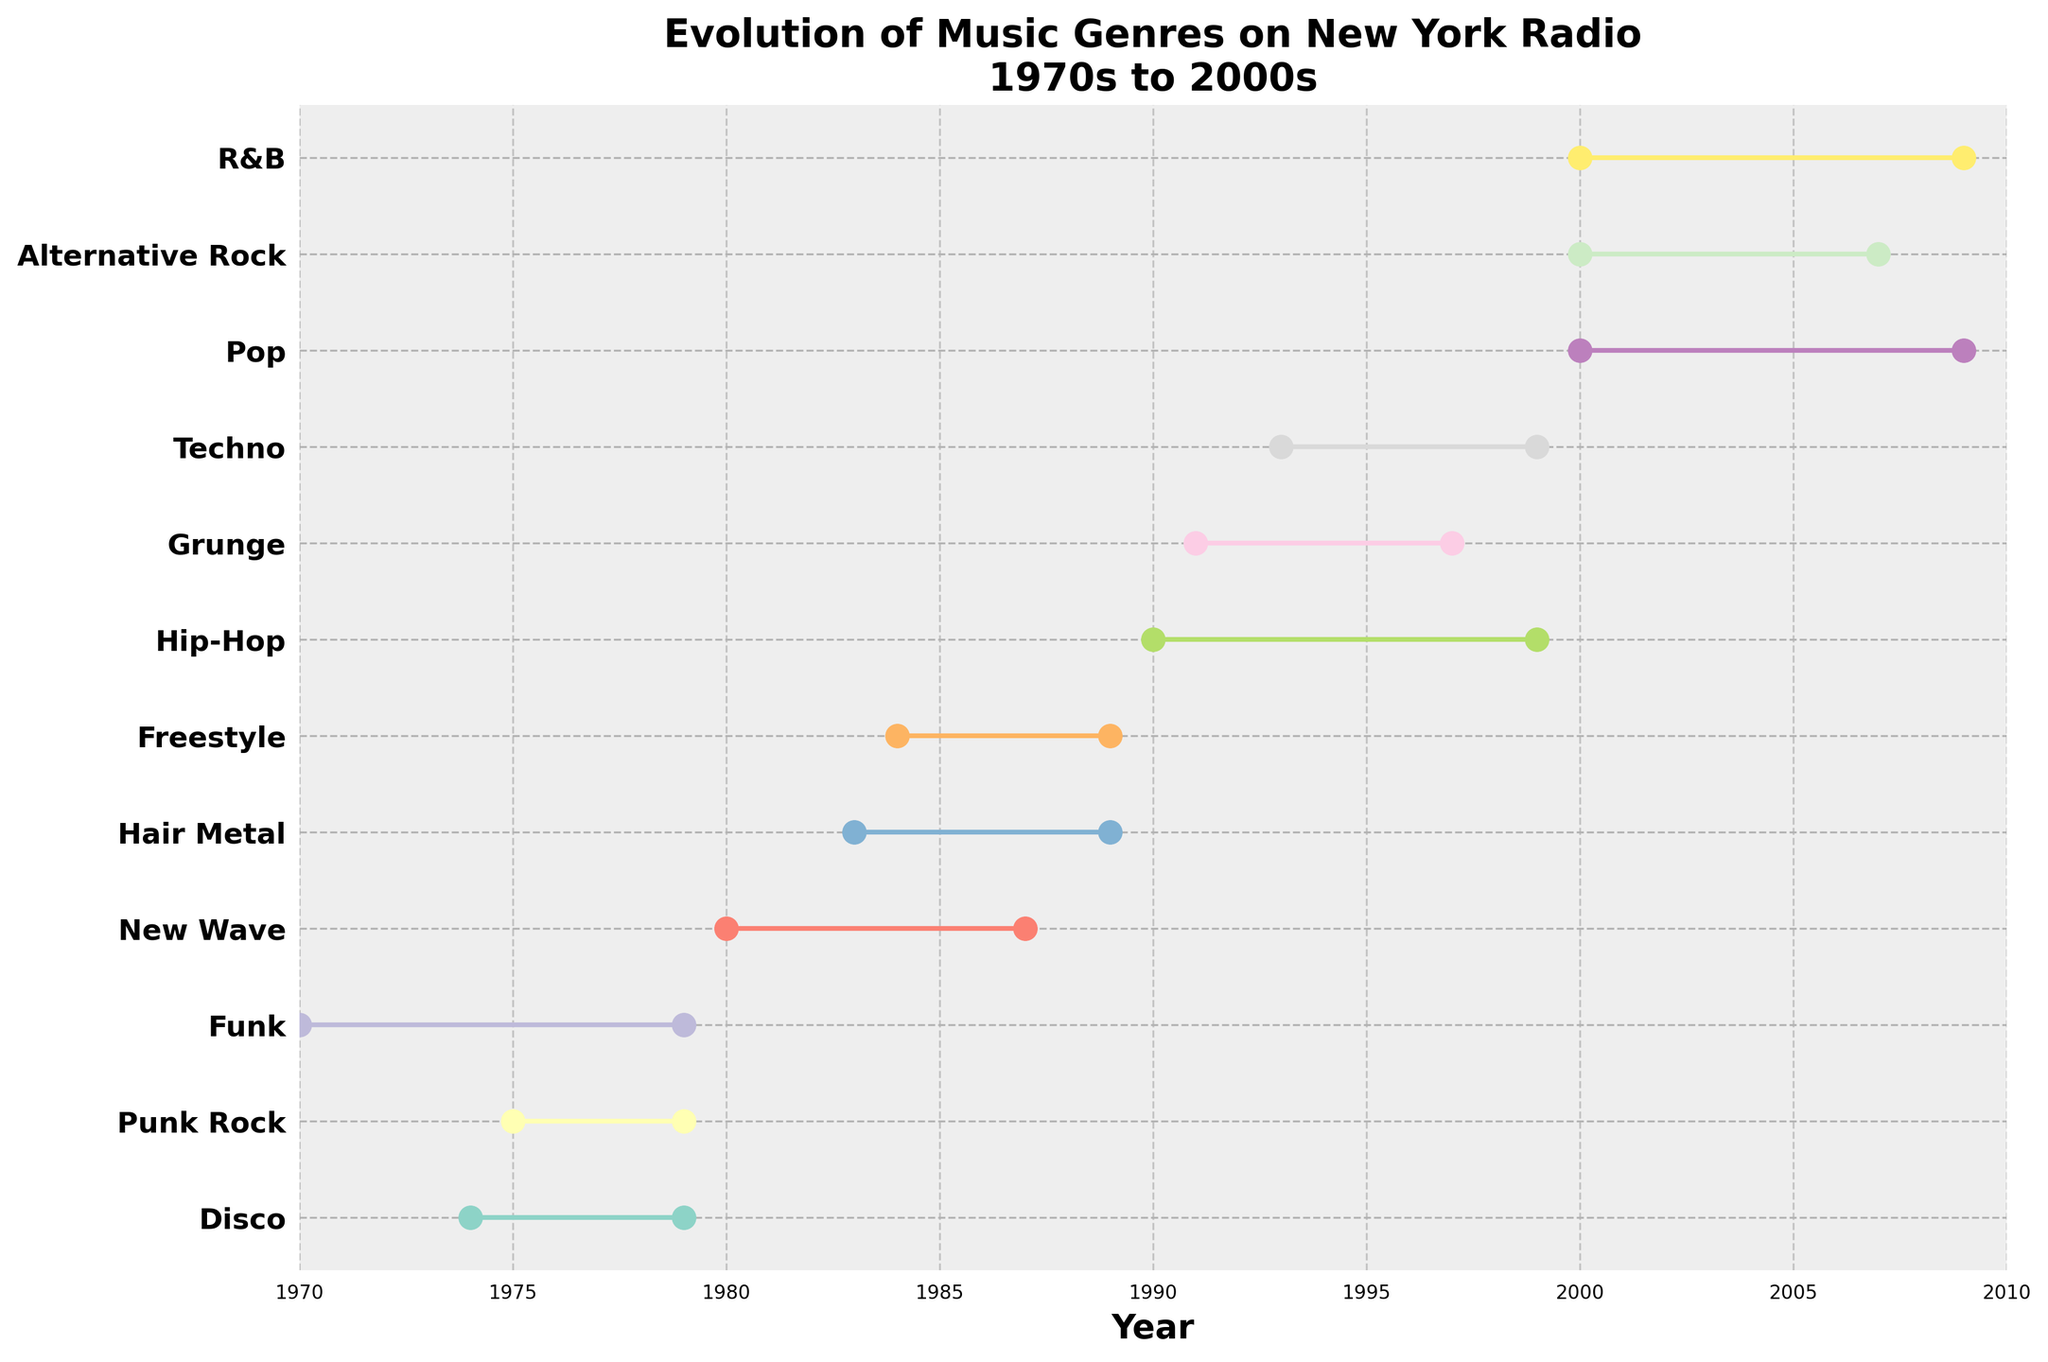When did Disco music start and end on New York radio? Based on the figure, Disco music started in 1974 and ended in 1979 on New York radio. Look at the points and lines associated with Disco.
Answer: 1974 to 1979 What's the title of the plot? The title is written at the top of the plot, summarizing its content and focus.
Answer: Evolution of Music Genres on New York Radio\n1970s to 2000s Which decade had the most music genres represented? Count the number of genres visualized for each decade by observing how many unique ranges are associated with each decade. The 2000s have three genres represented (Pop, Alternative Rock, and R&B).
Answer: 2000s How long did Hip-Hop music play on New York radio? Identify the start and end points for Hip-Hop, which is labeled on the y-axis. The plot shows Hip-Hop started in 1990 and ended in 1999, a total span calculated as 1999 - 1990 = 9 years.
Answer: 9 years Compare the duration of New Wave and Hair Metal. Which genre was played for a longer period? Check the start and end points of both genres. New Wave ran from 1980 to 1987 (7 years) and Hair Metal from 1983 to 1989 (6 years). Compare the durations.
Answer: New Wave Which genre had the longest continuous play on New York radio? Calculate the duration for each genre by subtracting the start year from the end year, and identify the largest value. Funk played from 1970 to 1979 spans 9 years.
Answer: Funk During which decades was Alternative Rock played on New York radio? Check where Alternative Rock appears on the y-axis and see the start and end points, belonging within the 2000s (2000 to 2007).
Answer: 2000s How many genres were played from 2000 to 2009? Analyze all the start and end points between the years 2000 and 2009, counting the number of unique genres falling within these years: Pop, Alternative Rock, and R&B.
Answer: 3 genres 